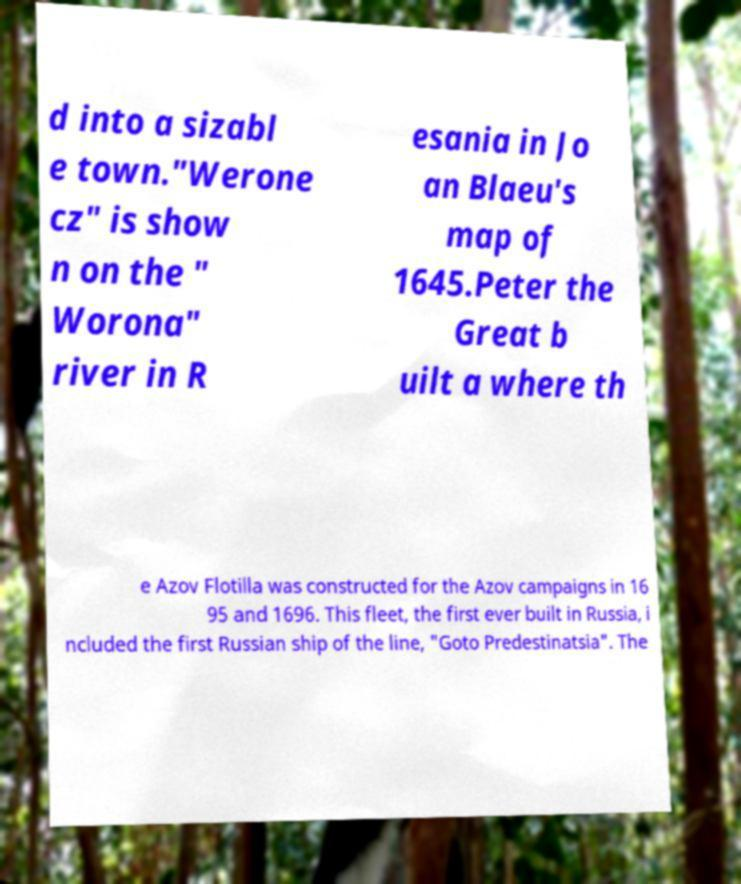Could you assist in decoding the text presented in this image and type it out clearly? d into a sizabl e town."Werone cz" is show n on the " Worona" river in R esania in Jo an Blaeu's map of 1645.Peter the Great b uilt a where th e Azov Flotilla was constructed for the Azov campaigns in 16 95 and 1696. This fleet, the first ever built in Russia, i ncluded the first Russian ship of the line, "Goto Predestinatsia". The 